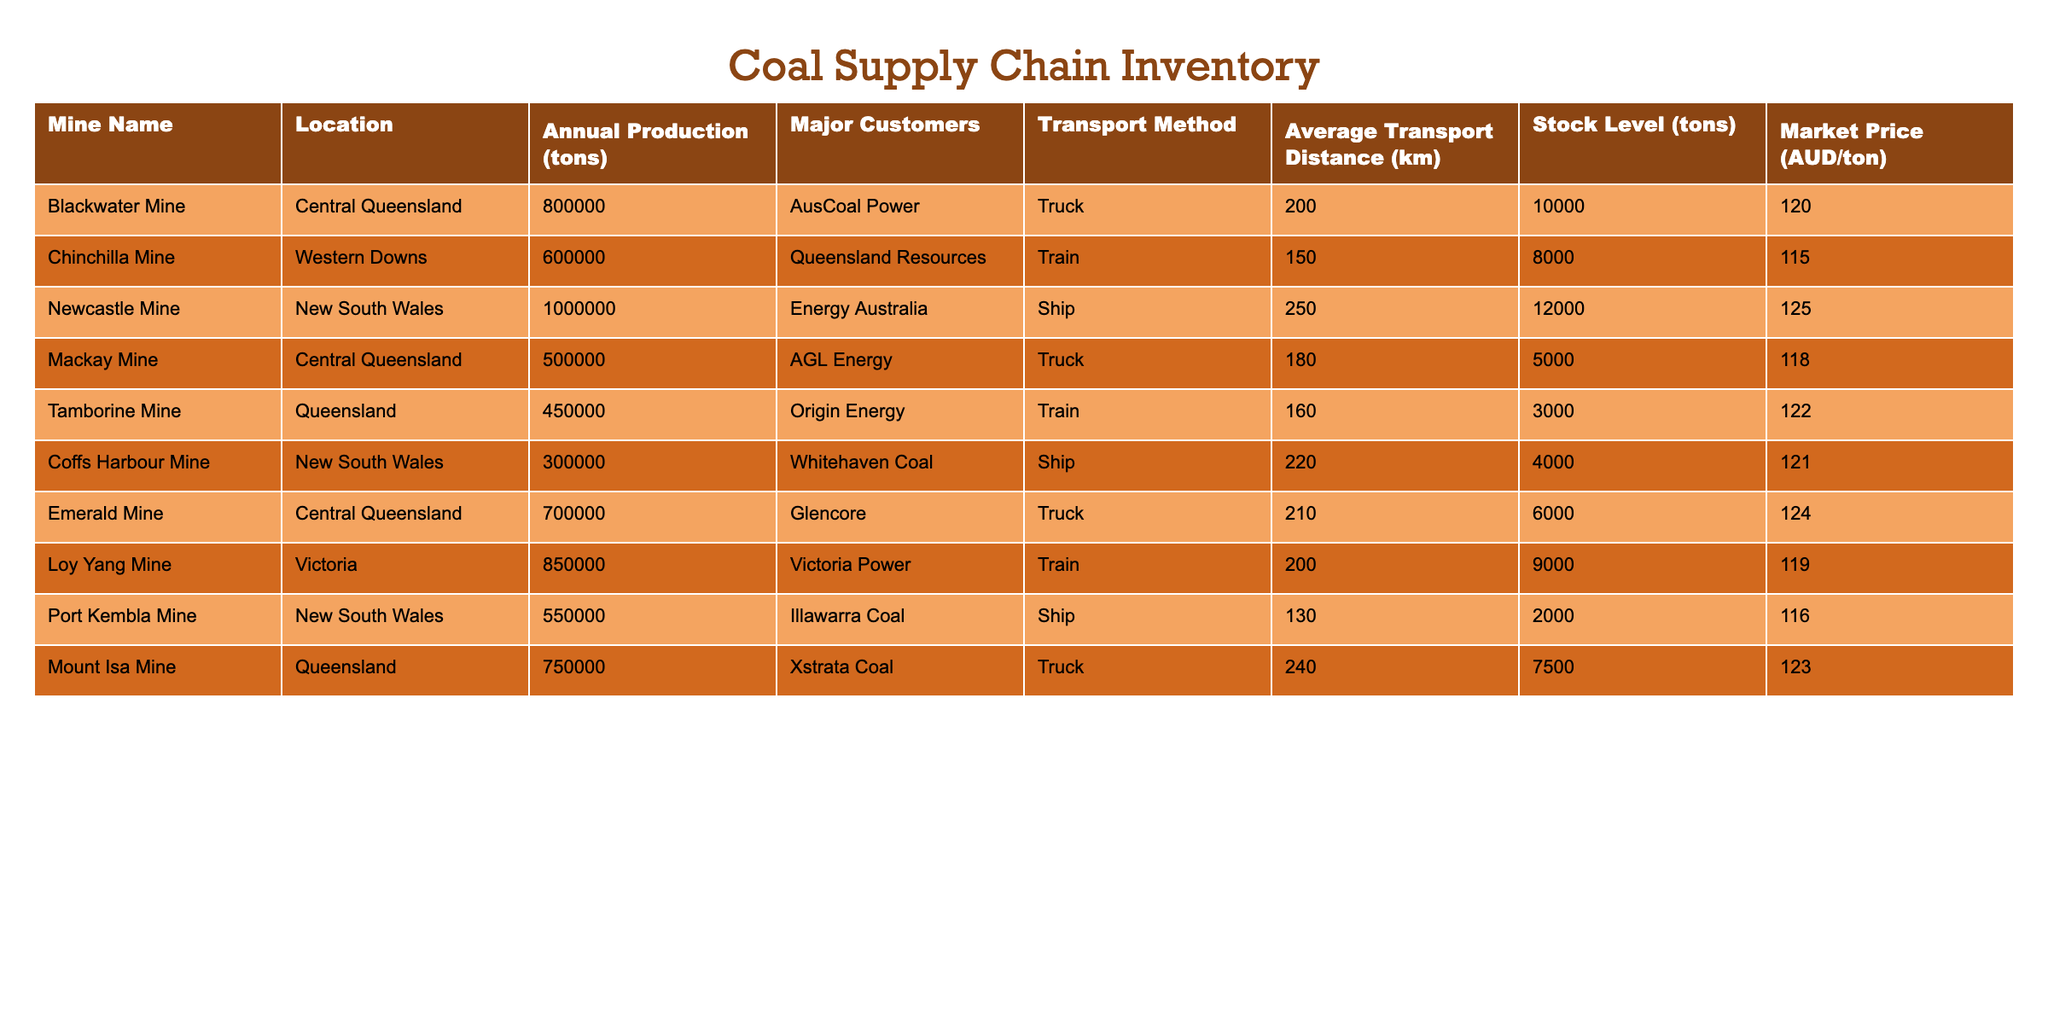What is the annual production of the Blackwater Mine? The table lists the Blackwater Mine with an annual production of 800,000 tons.
Answer: 800,000 tons Which mine has the highest market price per ton? To find the highest market price, I compare the prices in the Market Price column. The Newcastle Mine has the highest price of 125 AUD/ton.
Answer: 125 AUD/ton What is the total annual production of coal from the Central Queensland mines? The mines in Central Queensland are Blackwater Mine (800,000 tons), Mackay Mine (500,000 tons), and Emerald Mine (700,000 tons). Adding these gives: 800,000 + 500,000 + 700,000 = 2,000,000 tons.
Answer: 2,000,000 tons Is it true that the Port Kembla Mine has an average transport distance less than 150 km? The table indicates that the average transport distance for the Port Kembla Mine is 130 km, which is less than 150 km, making the statement true.
Answer: Yes What is the difference in stock levels between the Newcastle Mine and the Tamborine Mine? The stock level for Newcastle Mine is 12,000 tons and for Tamborine Mine is 3,000 tons. The difference is 12,000 - 3,000 = 9,000 tons.
Answer: 9,000 tons How much coal is transported by ship compared to truck? For ship transport: Newcastle Mine (1,000,000 tons), Coffs Harbour Mine (300,000 tons), Port Kembla Mine (550,000 tons) totals to 1,850,000 tons. For truck transport: Blackwater Mine (800,000 tons), Mackay Mine (500,000 tons), Emerald Mine (700,000 tons), Mount Isa Mine (750,000 tons) totals to 2,750,000 tons. Truck transport is greater.
Answer: Truck transport is greater What is the average market price of coal across all mines? To find the average market price, sum the prices: (120 + 115 + 125 + 118 + 122 + 121 + 124 + 119 + 116 + 123) = 1,400. Dividing this by the number of mines (10) gives an average price of 1,400 / 10 = 140 AUD/ton.
Answer: 140 AUD/ton Does the Mackay Mine have a stock level above 6,000 tons? The stock level for Mackay Mine is 5,000 tons, which is not above 6,000 tons. Hence, the statement is false.
Answer: No Which mine in Queensland has the lowest stock level? Reviewing the stock levels of Queensland mines reveals that the Tamborine Mine has the lowest stock level at 3,000 tons.
Answer: Tamborine Mine 